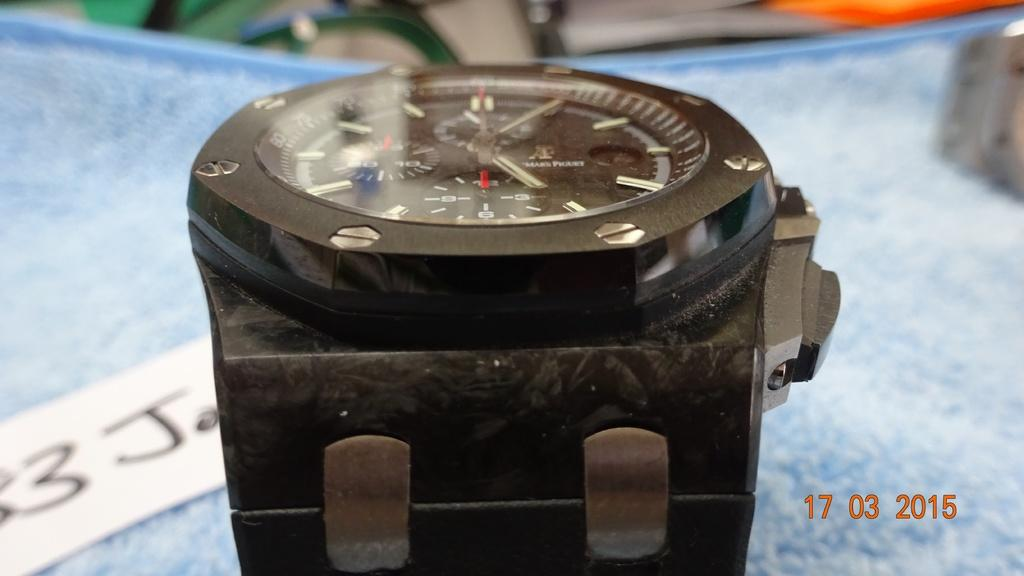Provide a one-sentence caption for the provided image. A photo of a black wrist watch was taken on March 17, 2015. 